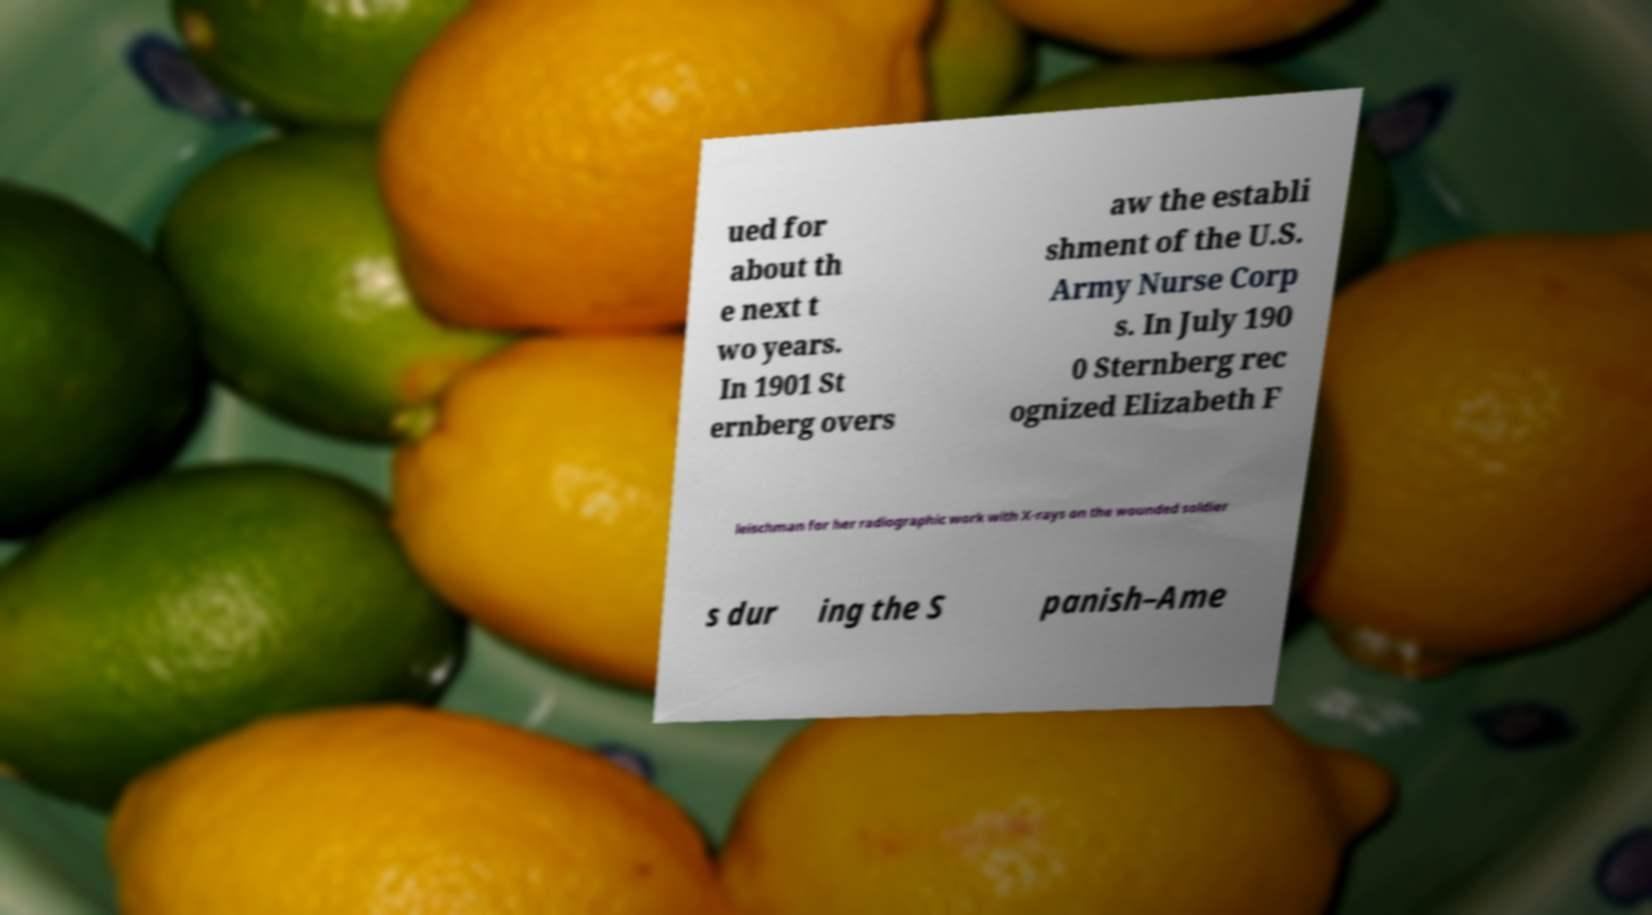Could you extract and type out the text from this image? ued for about th e next t wo years. In 1901 St ernberg overs aw the establi shment of the U.S. Army Nurse Corp s. In July 190 0 Sternberg rec ognized Elizabeth F leischman for her radiographic work with X-rays on the wounded soldier s dur ing the S panish–Ame 